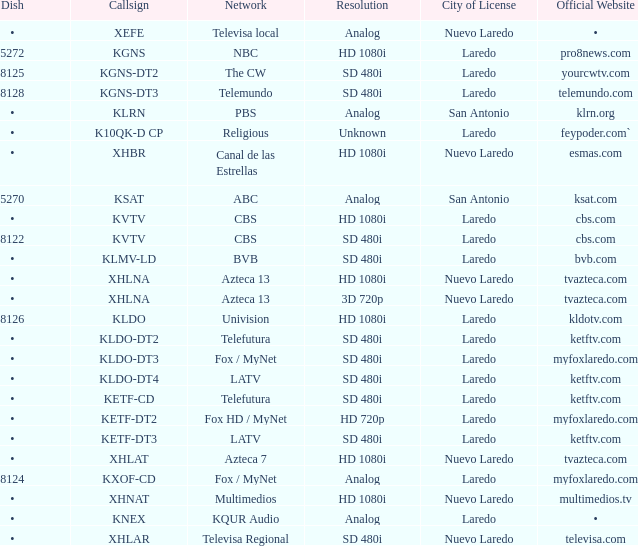Give me the full table as a dictionary. {'header': ['Dish', 'Callsign', 'Network', 'Resolution', 'City of License', 'Official Website'], 'rows': [['•', 'XEFE', 'Televisa local', 'Analog', 'Nuevo Laredo', '•'], ['5272', 'KGNS', 'NBC', 'HD 1080i', 'Laredo', 'pro8news.com'], ['8125', 'KGNS-DT2', 'The CW', 'SD 480i', 'Laredo', 'yourcwtv.com'], ['8128', 'KGNS-DT3', 'Telemundo', 'SD 480i', 'Laredo', 'telemundo.com'], ['•', 'KLRN', 'PBS', 'Analog', 'San Antonio', 'klrn.org'], ['•', 'K10QK-D CP', 'Religious', 'Unknown', 'Laredo', 'feypoder.com`'], ['•', 'XHBR', 'Canal de las Estrellas', 'HD 1080i', 'Nuevo Laredo', 'esmas.com'], ['5270', 'KSAT', 'ABC', 'Analog', 'San Antonio', 'ksat.com'], ['•', 'KVTV', 'CBS', 'HD 1080i', 'Laredo', 'cbs.com'], ['8122', 'KVTV', 'CBS', 'SD 480i', 'Laredo', 'cbs.com'], ['•', 'KLMV-LD', 'BVB', 'SD 480i', 'Laredo', 'bvb.com'], ['•', 'XHLNA', 'Azteca 13', 'HD 1080i', 'Nuevo Laredo', 'tvazteca.com'], ['•', 'XHLNA', 'Azteca 13', '3D 720p', 'Nuevo Laredo', 'tvazteca.com'], ['8126', 'KLDO', 'Univision', 'HD 1080i', 'Laredo', 'kldotv.com'], ['•', 'KLDO-DT2', 'Telefutura', 'SD 480i', 'Laredo', 'ketftv.com'], ['•', 'KLDO-DT3', 'Fox / MyNet', 'SD 480i', 'Laredo', 'myfoxlaredo.com'], ['•', 'KLDO-DT4', 'LATV', 'SD 480i', 'Laredo', 'ketftv.com'], ['•', 'KETF-CD', 'Telefutura', 'SD 480i', 'Laredo', 'ketftv.com'], ['•', 'KETF-DT2', 'Fox HD / MyNet', 'HD 720p', 'Laredo', 'myfoxlaredo.com'], ['•', 'KETF-DT3', 'LATV', 'SD 480i', 'Laredo', 'ketftv.com'], ['•', 'XHLAT', 'Azteca 7', 'HD 1080i', 'Nuevo Laredo', 'tvazteca.com'], ['8124', 'KXOF-CD', 'Fox / MyNet', 'Analog', 'Laredo', 'myfoxlaredo.com'], ['•', 'XHNAT', 'Multimedios', 'HD 1080i', 'Nuevo Laredo', 'multimedios.tv'], ['•', 'KNEX', 'KQUR Audio', 'Analog', 'Laredo', '•'], ['•', 'XHLAR', 'Televisa Regional', 'SD 480i', 'Nuevo Laredo', 'televisa.com']]} Can you identify the dish that has a 480i sd resolution and is associated with the bvb network? •. 